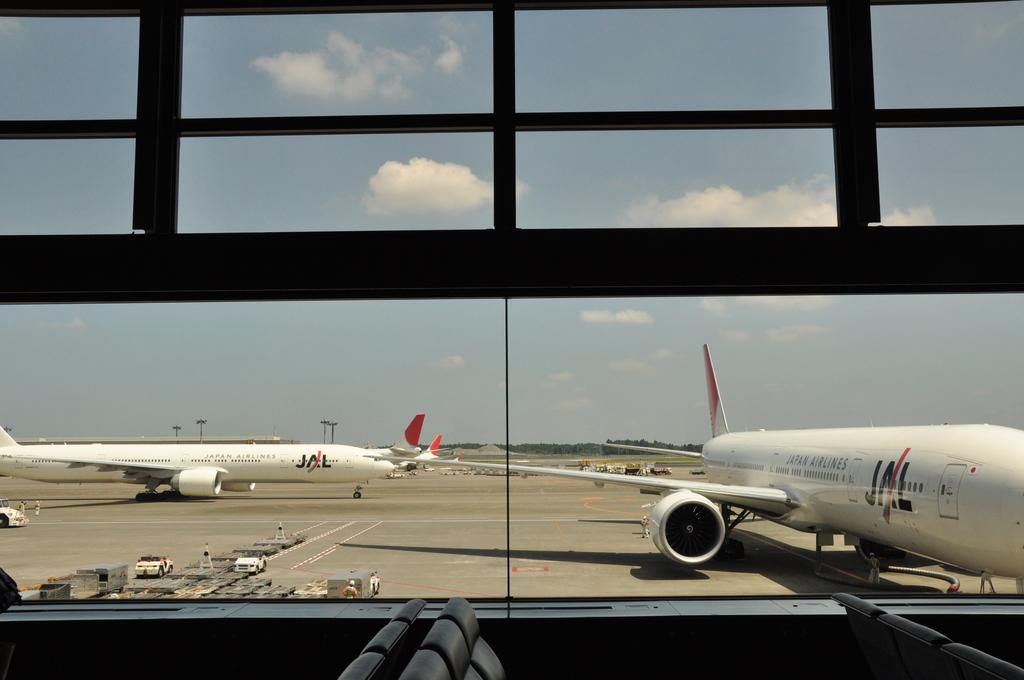What is the main subject of the image? The main subject of the image is a plane on the ground. What else can be seen in the image? There is a vehicle at the bottom left corner of the image. What is visible in the background of the image? The background of the image is the sky. What type of thread is being used by the cat in the image? There is no cat present in the image, and therefore no thread or related activity can be observed. 